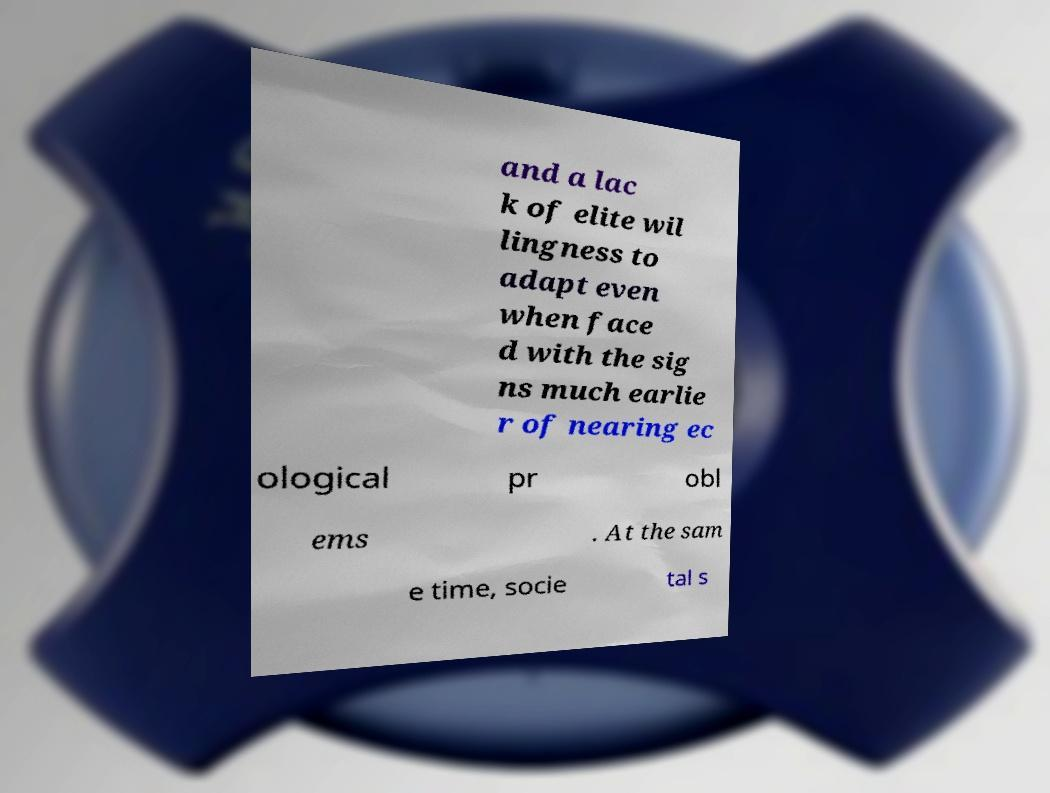Please identify and transcribe the text found in this image. and a lac k of elite wil lingness to adapt even when face d with the sig ns much earlie r of nearing ec ological pr obl ems . At the sam e time, socie tal s 